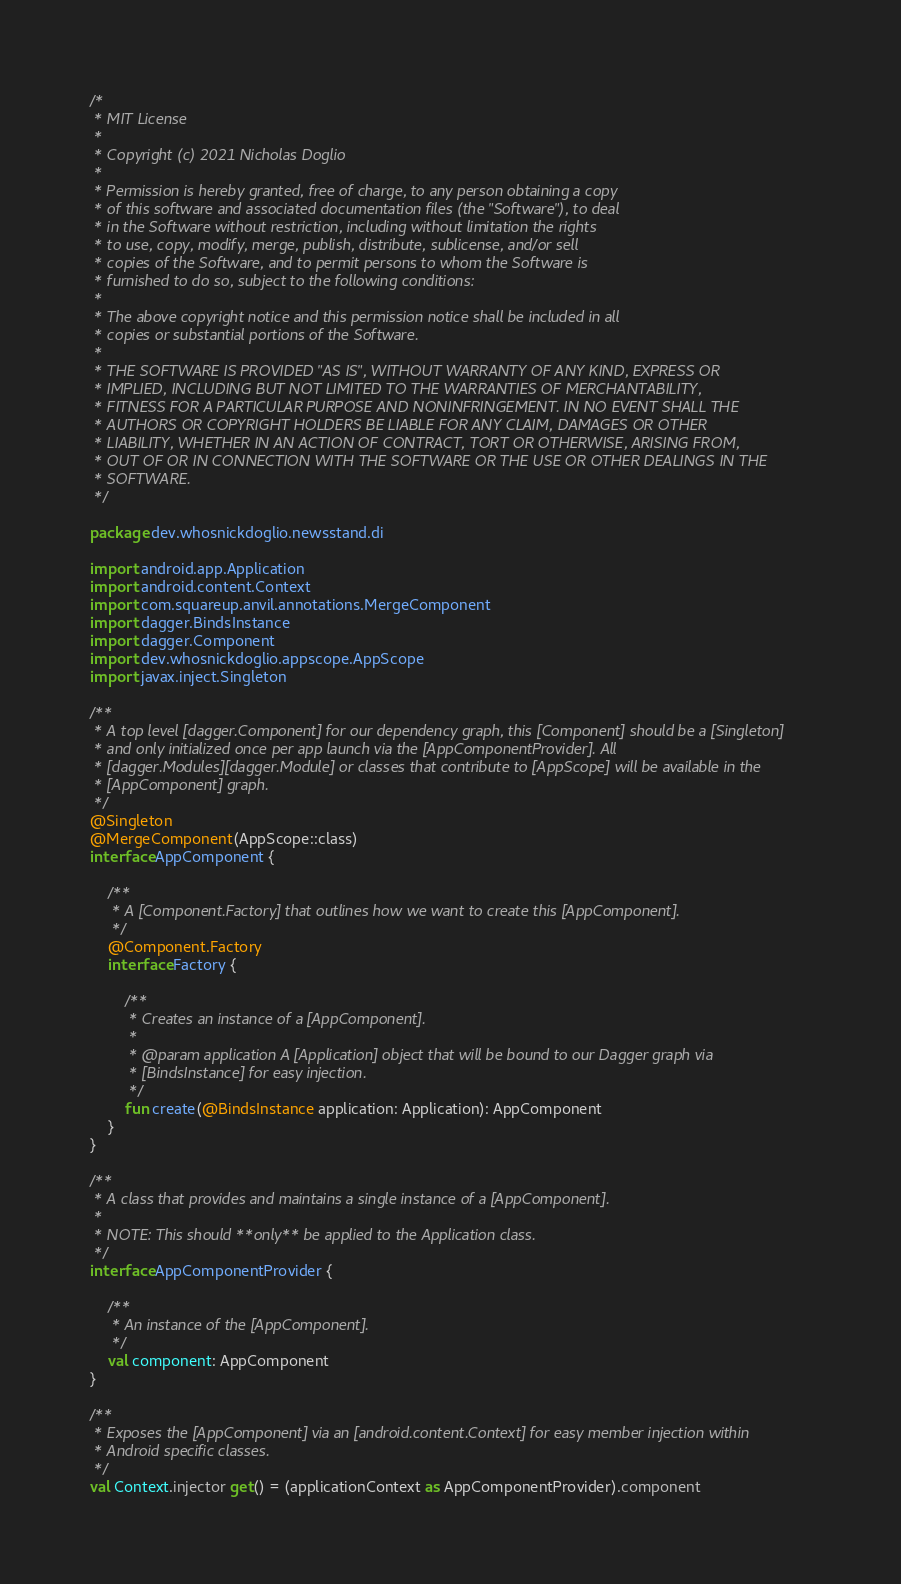<code> <loc_0><loc_0><loc_500><loc_500><_Kotlin_>/*
 * MIT License
 *
 * Copyright (c) 2021 Nicholas Doglio
 *
 * Permission is hereby granted, free of charge, to any person obtaining a copy
 * of this software and associated documentation files (the "Software"), to deal
 * in the Software without restriction, including without limitation the rights
 * to use, copy, modify, merge, publish, distribute, sublicense, and/or sell
 * copies of the Software, and to permit persons to whom the Software is
 * furnished to do so, subject to the following conditions:
 *
 * The above copyright notice and this permission notice shall be included in all
 * copies or substantial portions of the Software.
 *
 * THE SOFTWARE IS PROVIDED "AS IS", WITHOUT WARRANTY OF ANY KIND, EXPRESS OR
 * IMPLIED, INCLUDING BUT NOT LIMITED TO THE WARRANTIES OF MERCHANTABILITY,
 * FITNESS FOR A PARTICULAR PURPOSE AND NONINFRINGEMENT. IN NO EVENT SHALL THE
 * AUTHORS OR COPYRIGHT HOLDERS BE LIABLE FOR ANY CLAIM, DAMAGES OR OTHER
 * LIABILITY, WHETHER IN AN ACTION OF CONTRACT, TORT OR OTHERWISE, ARISING FROM,
 * OUT OF OR IN CONNECTION WITH THE SOFTWARE OR THE USE OR OTHER DEALINGS IN THE
 * SOFTWARE.
 */

package dev.whosnickdoglio.newsstand.di

import android.app.Application
import android.content.Context
import com.squareup.anvil.annotations.MergeComponent
import dagger.BindsInstance
import dagger.Component
import dev.whosnickdoglio.appscope.AppScope
import javax.inject.Singleton

/**
 * A top level [dagger.Component] for our dependency graph, this [Component] should be a [Singleton]
 * and only initialized once per app launch via the [AppComponentProvider]. All
 * [dagger.Modules][dagger.Module] or classes that contribute to [AppScope] will be available in the
 * [AppComponent] graph.
 */
@Singleton
@MergeComponent(AppScope::class)
interface AppComponent {

    /**
     * A [Component.Factory] that outlines how we want to create this [AppComponent].
     */
    @Component.Factory
    interface Factory {

        /**
         * Creates an instance of a [AppComponent].
         *
         * @param application A [Application] object that will be bound to our Dagger graph via
         * [BindsInstance] for easy injection.
         */
        fun create(@BindsInstance application: Application): AppComponent
    }
}

/**
 * A class that provides and maintains a single instance of a [AppComponent].
 *
 * NOTE: This should **only** be applied to the Application class.
 */
interface AppComponentProvider {

    /**
     * An instance of the [AppComponent].
     */
    val component: AppComponent
}

/**
 * Exposes the [AppComponent] via an [android.content.Context] for easy member injection within
 * Android specific classes.
 */
val Context.injector get() = (applicationContext as AppComponentProvider).component
</code> 